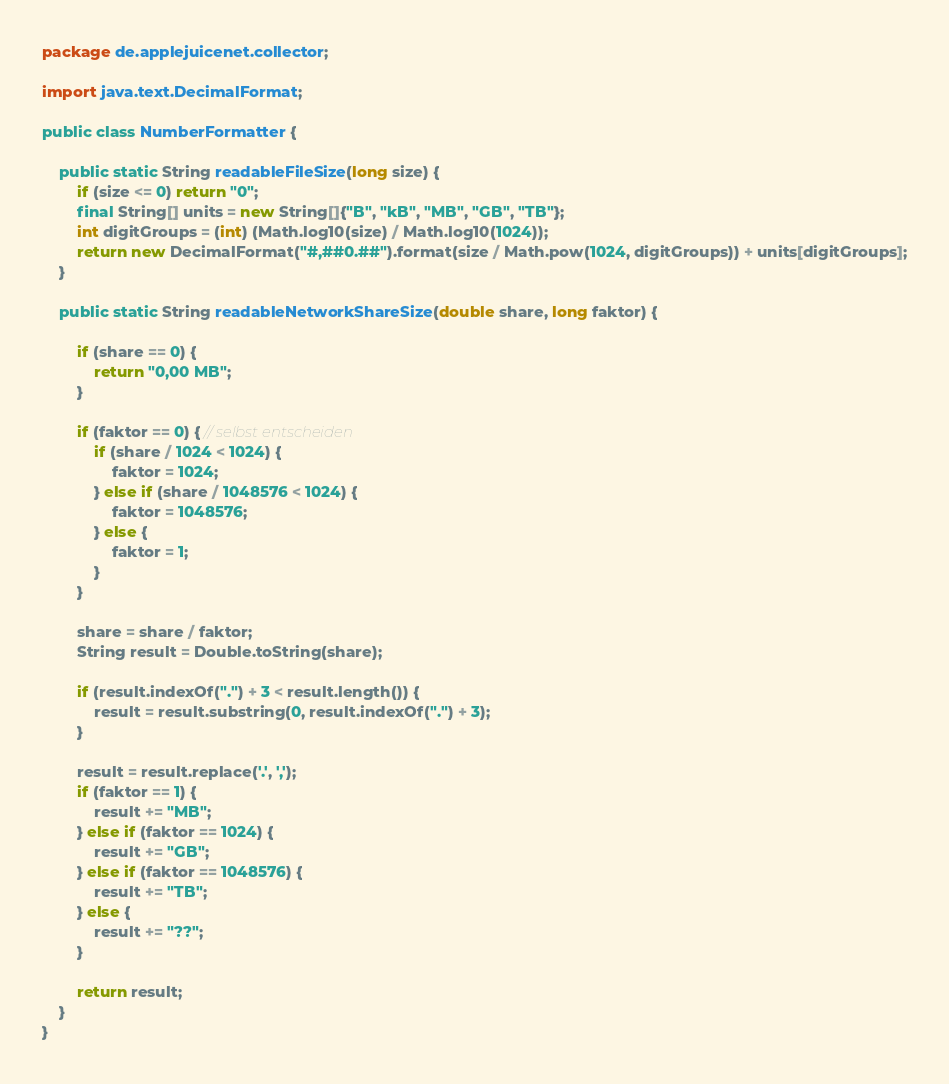<code> <loc_0><loc_0><loc_500><loc_500><_Java_>package de.applejuicenet.collector;

import java.text.DecimalFormat;

public class NumberFormatter {

    public static String readableFileSize(long size) {
        if (size <= 0) return "0";
        final String[] units = new String[]{"B", "kB", "MB", "GB", "TB"};
        int digitGroups = (int) (Math.log10(size) / Math.log10(1024));
        return new DecimalFormat("#,##0.##").format(size / Math.pow(1024, digitGroups)) + units[digitGroups];
    }

    public static String readableNetworkShareSize(double share, long faktor) {

        if (share == 0) {
            return "0,00 MB";
        }

        if (faktor == 0) { // selbst entscheiden
            if (share / 1024 < 1024) {
                faktor = 1024;
            } else if (share / 1048576 < 1024) {
                faktor = 1048576;
            } else {
                faktor = 1;
            }
        }

        share = share / faktor;
        String result = Double.toString(share);

        if (result.indexOf(".") + 3 < result.length()) {
            result = result.substring(0, result.indexOf(".") + 3);
        }

        result = result.replace('.', ',');
        if (faktor == 1) {
            result += "MB";
        } else if (faktor == 1024) {
            result += "GB";
        } else if (faktor == 1048576) {
            result += "TB";
        } else {
            result += "??";
        }

        return result;
    }
}
</code> 